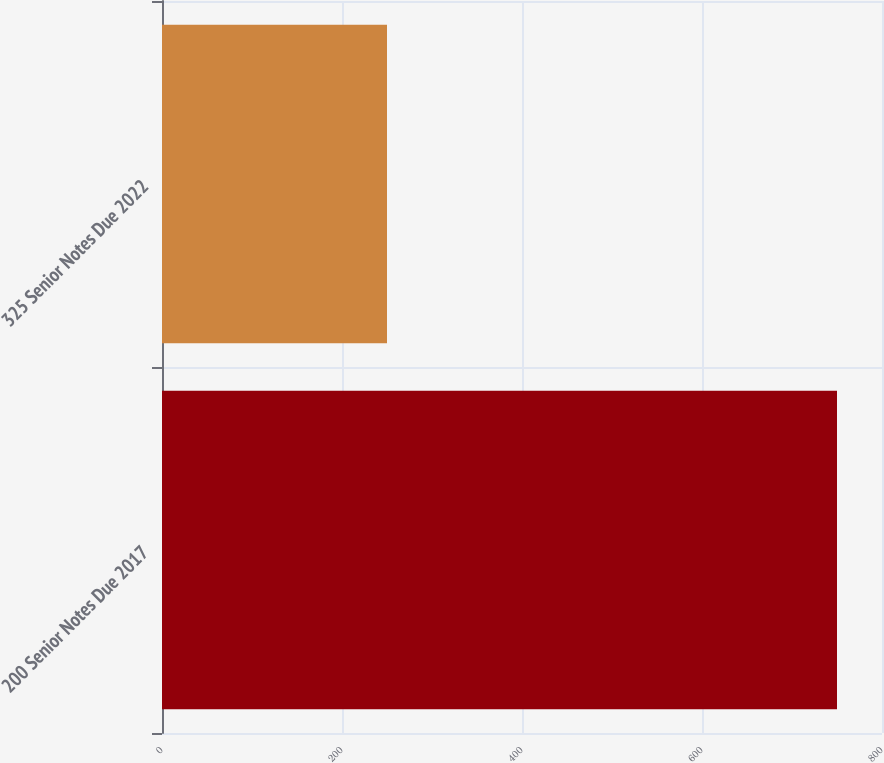Convert chart. <chart><loc_0><loc_0><loc_500><loc_500><bar_chart><fcel>200 Senior Notes Due 2017<fcel>325 Senior Notes Due 2022<nl><fcel>750<fcel>250<nl></chart> 